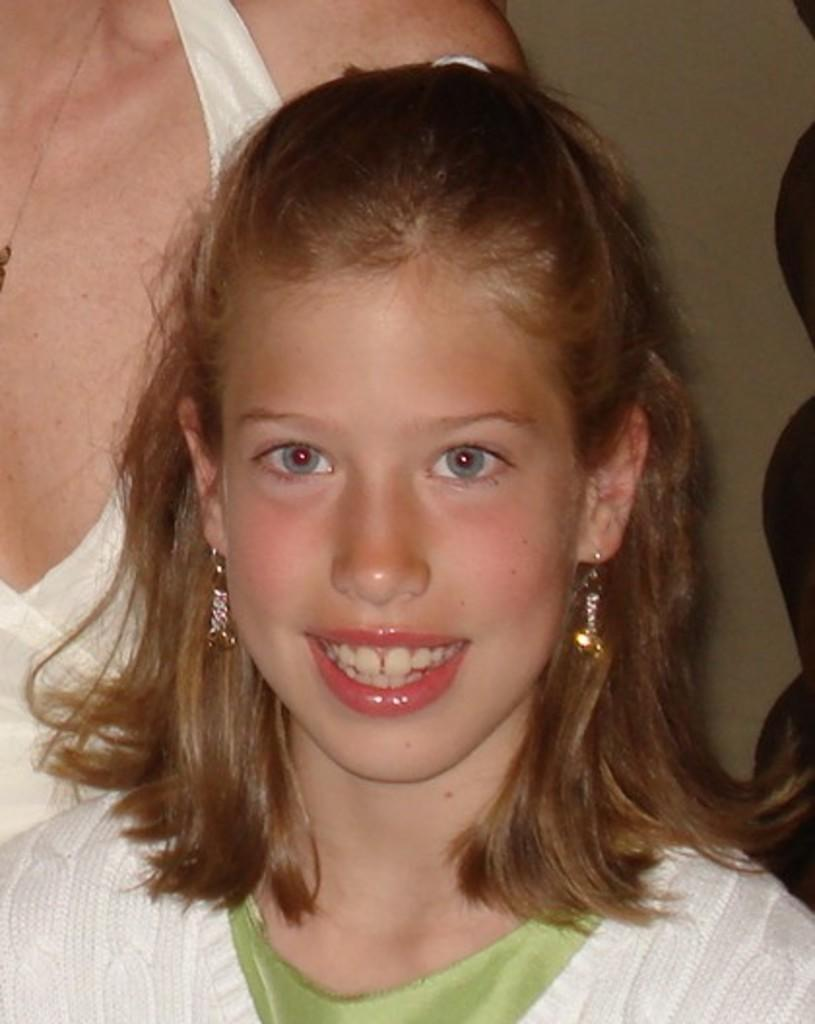Who is the main subject in the foreground of the image? There is a girl standing in the foreground of the image. Can you describe the background of the image? There is another person and a wall visible in the background of the image. What historical event is being commemorated by the girl and the person in the image? There is no indication of a historical event or commemoration in the image. 